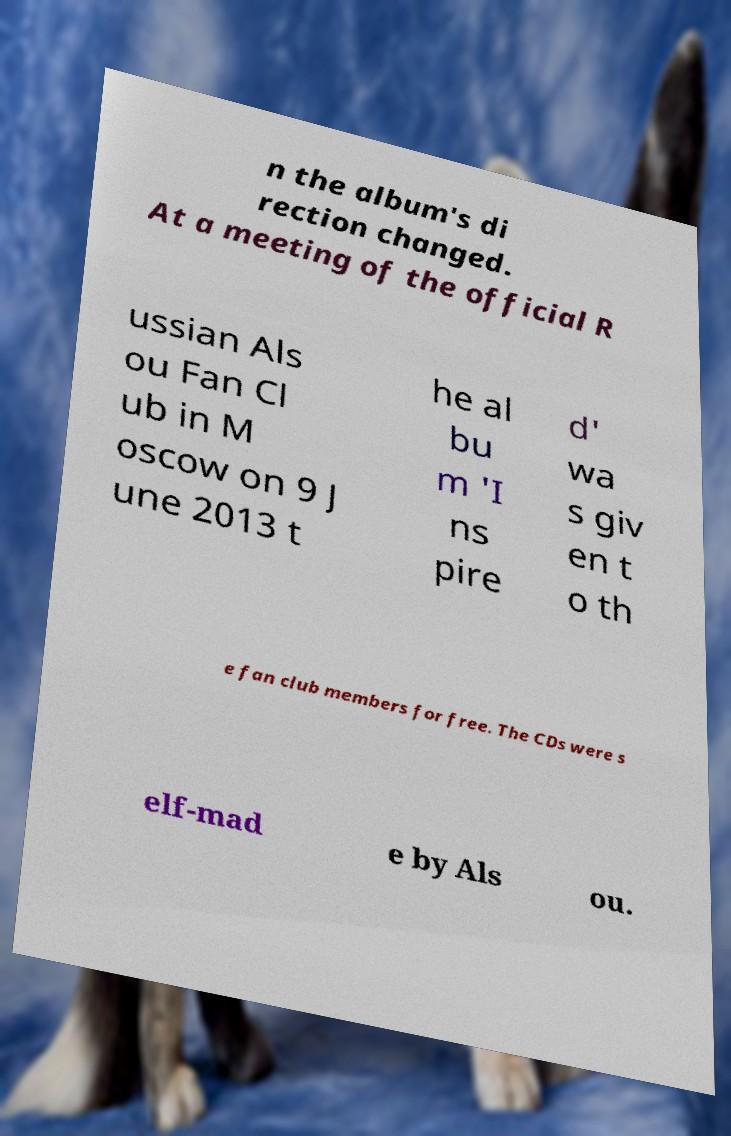Please read and relay the text visible in this image. What does it say? n the album's di rection changed. At a meeting of the official R ussian Als ou Fan Cl ub in M oscow on 9 J une 2013 t he al bu m 'I ns pire d' wa s giv en t o th e fan club members for free. The CDs were s elf-mad e by Als ou. 